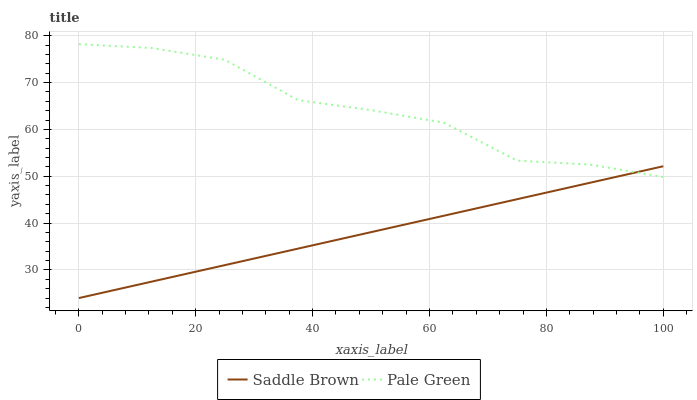Does Saddle Brown have the minimum area under the curve?
Answer yes or no. Yes. Does Pale Green have the maximum area under the curve?
Answer yes or no. Yes. Does Saddle Brown have the maximum area under the curve?
Answer yes or no. No. Is Saddle Brown the smoothest?
Answer yes or no. Yes. Is Pale Green the roughest?
Answer yes or no. Yes. Is Saddle Brown the roughest?
Answer yes or no. No. Does Saddle Brown have the lowest value?
Answer yes or no. Yes. Does Pale Green have the highest value?
Answer yes or no. Yes. Does Saddle Brown have the highest value?
Answer yes or no. No. Does Pale Green intersect Saddle Brown?
Answer yes or no. Yes. Is Pale Green less than Saddle Brown?
Answer yes or no. No. Is Pale Green greater than Saddle Brown?
Answer yes or no. No. 